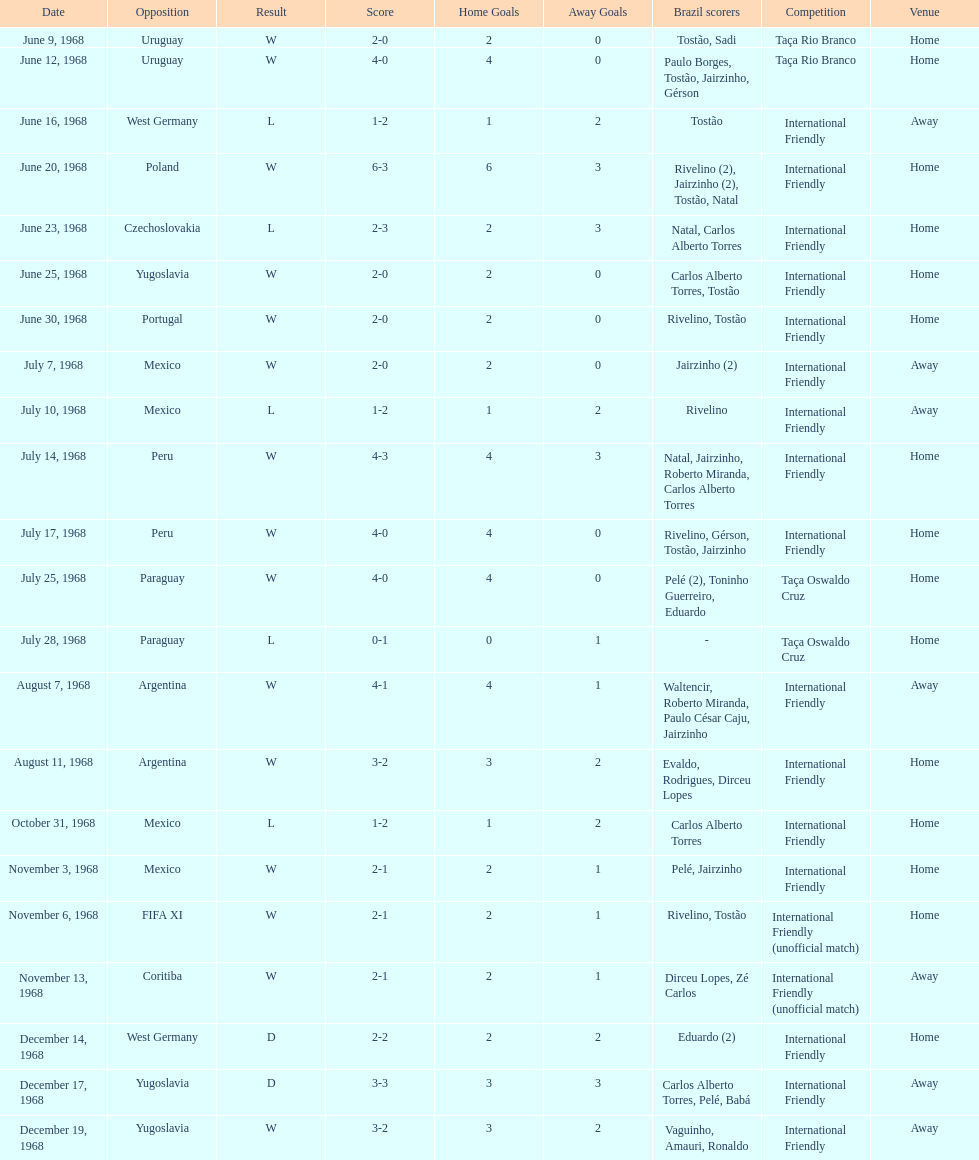What is the number of countries they have played? 11. 